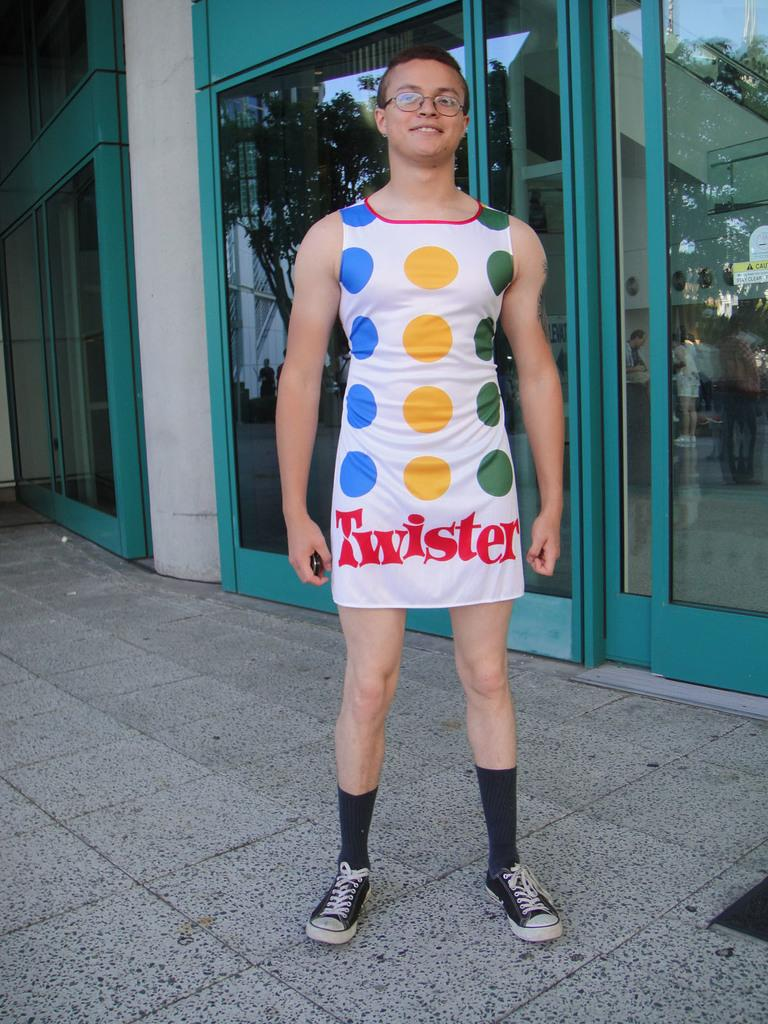Provide a one-sentence caption for the provided image. A young man in galsses stands outside a store wearing a twister themed dress. 